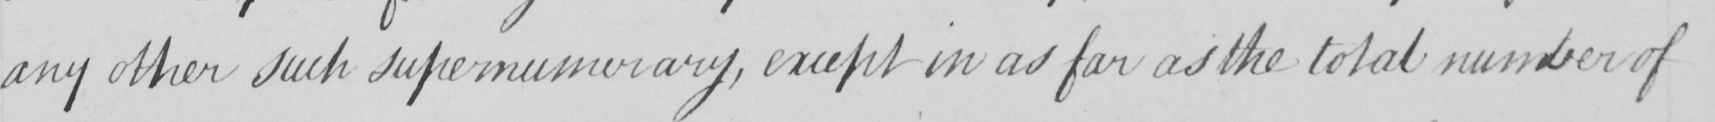Transcribe the text shown in this historical manuscript line. any other such supernumerary , except in as far as the total number of 